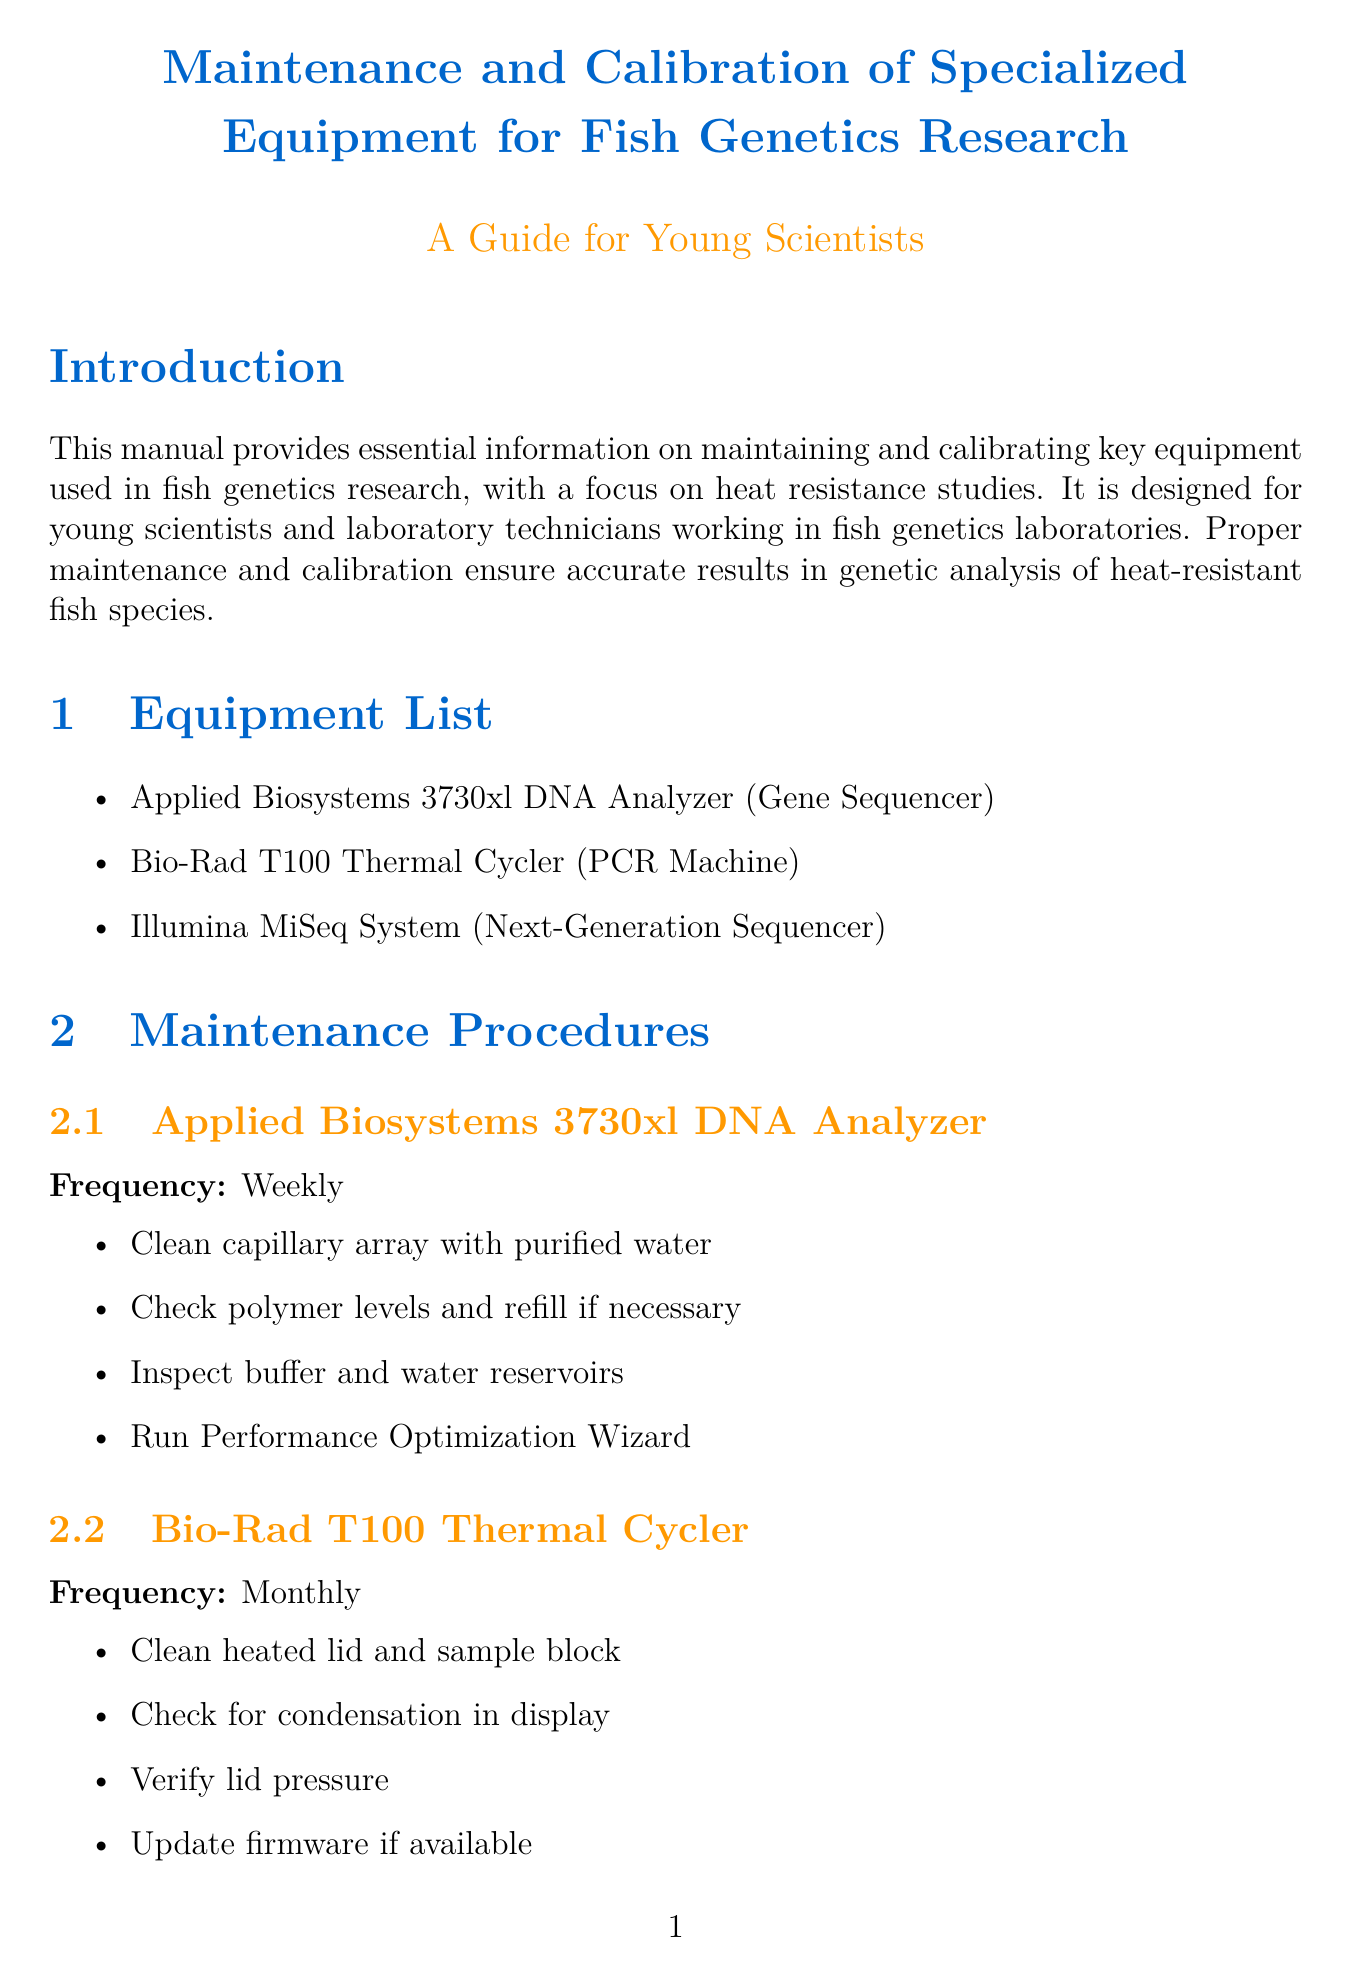What is the purpose of this manual? The purpose is to provide essential information on maintaining and calibrating key equipment used in fish genetics research, with a focus on heat resistance studies.
Answer: Essential information on maintaining and calibrating equipment for heat resistance studies Who is the target audience for this manual? The target audience is specified as young scientists and laboratory technicians working in fish genetics laboratories.
Answer: Young scientists and laboratory technicians How often should the Applied Biosystems 3730xl DNA Analyzer be maintained? The frequency of maintenance for this equipment is explicitly stated as weekly.
Answer: Weekly What is the first step in the maintenance procedure for the Bio-Rad T100 Thermal Cycler? The first step in the maintenance procedure is to clean the heated lid and sample block.
Answer: Clean heated lid and sample block What is the frequency of calibration for the Illumina MiSeq System? The frequency of calibration is indicated as annually.
Answer: Annually What are the possible causes of poor sequencing quality in heat-resistant fish samples? The document lists three possible causes for this issue.
Answer: Improper sample preparation, degraded reagents, miscalibrated equipment What should be done after each run of the Illumina MiSeq System? A specific procedure is mentioned that must be performed after each run.
Answer: Perform post-run wash How frequently should temperature verification be run for the Bio-Rad T100 Thermal Cycler? The frequency for this calibration is specified as quarterly.
Answer: Quarterly 